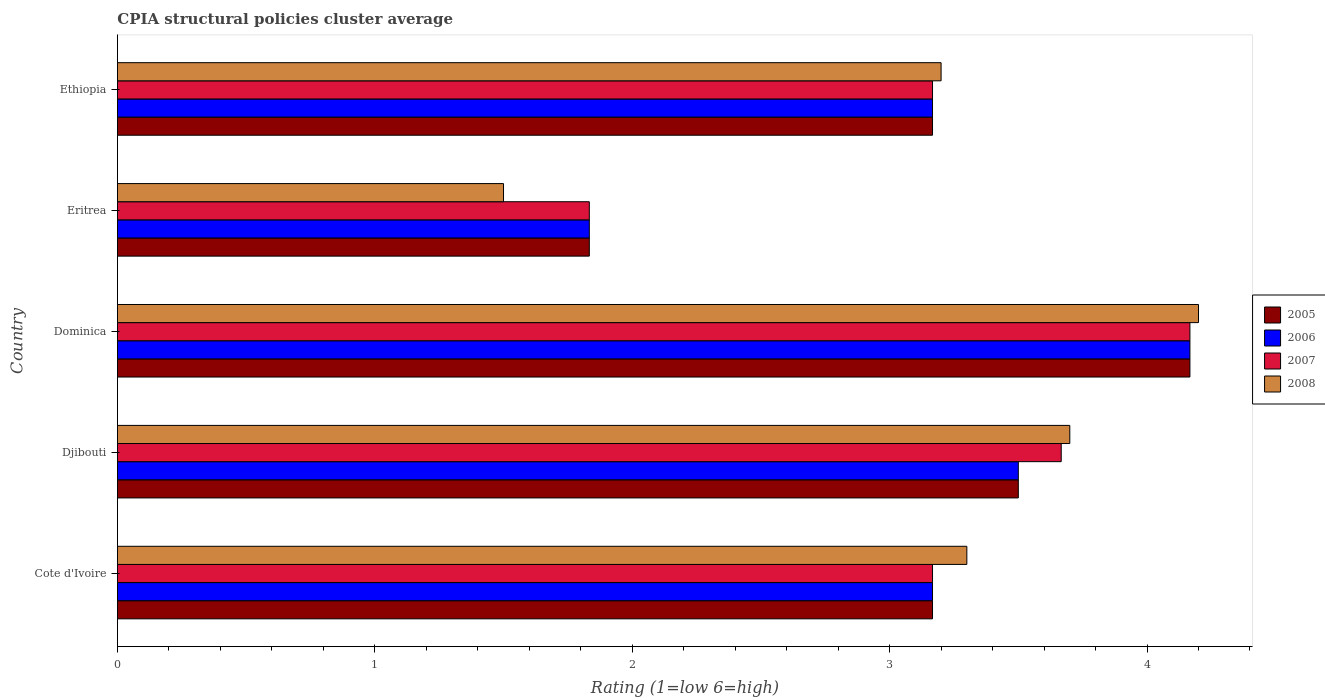How many groups of bars are there?
Ensure brevity in your answer.  5. Are the number of bars per tick equal to the number of legend labels?
Your answer should be compact. Yes. How many bars are there on the 2nd tick from the top?
Offer a very short reply. 4. What is the label of the 4th group of bars from the top?
Ensure brevity in your answer.  Djibouti. In how many cases, is the number of bars for a given country not equal to the number of legend labels?
Offer a terse response. 0. What is the CPIA rating in 2005 in Ethiopia?
Your answer should be compact. 3.17. Across all countries, what is the maximum CPIA rating in 2007?
Keep it short and to the point. 4.17. Across all countries, what is the minimum CPIA rating in 2005?
Give a very brief answer. 1.83. In which country was the CPIA rating in 2008 maximum?
Offer a terse response. Dominica. In which country was the CPIA rating in 2005 minimum?
Your answer should be very brief. Eritrea. What is the total CPIA rating in 2007 in the graph?
Keep it short and to the point. 16. What is the difference between the CPIA rating in 2005 in Cote d'Ivoire and that in Eritrea?
Keep it short and to the point. 1.33. What is the difference between the CPIA rating in 2005 in Ethiopia and the CPIA rating in 2006 in Djibouti?
Ensure brevity in your answer.  -0.33. What is the average CPIA rating in 2008 per country?
Provide a succinct answer. 3.18. What is the difference between the CPIA rating in 2005 and CPIA rating in 2007 in Djibouti?
Make the answer very short. -0.17. What is the ratio of the CPIA rating in 2006 in Dominica to that in Ethiopia?
Offer a terse response. 1.32. Is the difference between the CPIA rating in 2005 in Dominica and Eritrea greater than the difference between the CPIA rating in 2007 in Dominica and Eritrea?
Ensure brevity in your answer.  No. What is the difference between the highest and the second highest CPIA rating in 2006?
Your response must be concise. 0.67. What is the difference between the highest and the lowest CPIA rating in 2005?
Your response must be concise. 2.33. Is the sum of the CPIA rating in 2007 in Dominica and Ethiopia greater than the maximum CPIA rating in 2005 across all countries?
Give a very brief answer. Yes. What does the 3rd bar from the top in Dominica represents?
Give a very brief answer. 2006. Is it the case that in every country, the sum of the CPIA rating in 2008 and CPIA rating in 2006 is greater than the CPIA rating in 2005?
Provide a succinct answer. Yes. Are all the bars in the graph horizontal?
Your response must be concise. Yes. How many countries are there in the graph?
Provide a succinct answer. 5. What is the difference between two consecutive major ticks on the X-axis?
Make the answer very short. 1. Does the graph contain grids?
Your answer should be very brief. No. Where does the legend appear in the graph?
Offer a very short reply. Center right. What is the title of the graph?
Give a very brief answer. CPIA structural policies cluster average. Does "1968" appear as one of the legend labels in the graph?
Offer a very short reply. No. What is the label or title of the X-axis?
Your answer should be very brief. Rating (1=low 6=high). What is the Rating (1=low 6=high) of 2005 in Cote d'Ivoire?
Offer a terse response. 3.17. What is the Rating (1=low 6=high) of 2006 in Cote d'Ivoire?
Provide a succinct answer. 3.17. What is the Rating (1=low 6=high) of 2007 in Cote d'Ivoire?
Offer a terse response. 3.17. What is the Rating (1=low 6=high) of 2008 in Cote d'Ivoire?
Keep it short and to the point. 3.3. What is the Rating (1=low 6=high) in 2005 in Djibouti?
Provide a short and direct response. 3.5. What is the Rating (1=low 6=high) in 2007 in Djibouti?
Keep it short and to the point. 3.67. What is the Rating (1=low 6=high) in 2008 in Djibouti?
Give a very brief answer. 3.7. What is the Rating (1=low 6=high) in 2005 in Dominica?
Offer a very short reply. 4.17. What is the Rating (1=low 6=high) of 2006 in Dominica?
Your response must be concise. 4.17. What is the Rating (1=low 6=high) in 2007 in Dominica?
Give a very brief answer. 4.17. What is the Rating (1=low 6=high) in 2008 in Dominica?
Your response must be concise. 4.2. What is the Rating (1=low 6=high) of 2005 in Eritrea?
Make the answer very short. 1.83. What is the Rating (1=low 6=high) in 2006 in Eritrea?
Your response must be concise. 1.83. What is the Rating (1=low 6=high) of 2007 in Eritrea?
Keep it short and to the point. 1.83. What is the Rating (1=low 6=high) in 2005 in Ethiopia?
Your response must be concise. 3.17. What is the Rating (1=low 6=high) in 2006 in Ethiopia?
Provide a short and direct response. 3.17. What is the Rating (1=low 6=high) in 2007 in Ethiopia?
Provide a succinct answer. 3.17. What is the Rating (1=low 6=high) in 2008 in Ethiopia?
Your answer should be very brief. 3.2. Across all countries, what is the maximum Rating (1=low 6=high) in 2005?
Your answer should be very brief. 4.17. Across all countries, what is the maximum Rating (1=low 6=high) in 2006?
Your response must be concise. 4.17. Across all countries, what is the maximum Rating (1=low 6=high) in 2007?
Offer a terse response. 4.17. Across all countries, what is the maximum Rating (1=low 6=high) in 2008?
Your answer should be very brief. 4.2. Across all countries, what is the minimum Rating (1=low 6=high) of 2005?
Provide a succinct answer. 1.83. Across all countries, what is the minimum Rating (1=low 6=high) in 2006?
Give a very brief answer. 1.83. Across all countries, what is the minimum Rating (1=low 6=high) of 2007?
Your answer should be compact. 1.83. Across all countries, what is the minimum Rating (1=low 6=high) of 2008?
Provide a succinct answer. 1.5. What is the total Rating (1=low 6=high) in 2005 in the graph?
Provide a short and direct response. 15.83. What is the total Rating (1=low 6=high) of 2006 in the graph?
Give a very brief answer. 15.83. What is the total Rating (1=low 6=high) in 2008 in the graph?
Offer a terse response. 15.9. What is the difference between the Rating (1=low 6=high) of 2006 in Cote d'Ivoire and that in Djibouti?
Your answer should be very brief. -0.33. What is the difference between the Rating (1=low 6=high) in 2006 in Cote d'Ivoire and that in Dominica?
Make the answer very short. -1. What is the difference between the Rating (1=low 6=high) in 2007 in Cote d'Ivoire and that in Dominica?
Provide a short and direct response. -1. What is the difference between the Rating (1=low 6=high) in 2008 in Cote d'Ivoire and that in Eritrea?
Keep it short and to the point. 1.8. What is the difference between the Rating (1=low 6=high) of 2006 in Cote d'Ivoire and that in Ethiopia?
Your answer should be compact. 0. What is the difference between the Rating (1=low 6=high) of 2007 in Cote d'Ivoire and that in Ethiopia?
Your answer should be compact. 0. What is the difference between the Rating (1=low 6=high) in 2008 in Cote d'Ivoire and that in Ethiopia?
Provide a succinct answer. 0.1. What is the difference between the Rating (1=low 6=high) in 2007 in Djibouti and that in Eritrea?
Give a very brief answer. 1.83. What is the difference between the Rating (1=low 6=high) of 2008 in Djibouti and that in Eritrea?
Give a very brief answer. 2.2. What is the difference between the Rating (1=low 6=high) of 2006 in Djibouti and that in Ethiopia?
Your answer should be compact. 0.33. What is the difference between the Rating (1=low 6=high) of 2008 in Djibouti and that in Ethiopia?
Keep it short and to the point. 0.5. What is the difference between the Rating (1=low 6=high) in 2005 in Dominica and that in Eritrea?
Make the answer very short. 2.33. What is the difference between the Rating (1=low 6=high) in 2006 in Dominica and that in Eritrea?
Your answer should be compact. 2.33. What is the difference between the Rating (1=low 6=high) of 2007 in Dominica and that in Eritrea?
Your answer should be compact. 2.33. What is the difference between the Rating (1=low 6=high) in 2008 in Dominica and that in Eritrea?
Make the answer very short. 2.7. What is the difference between the Rating (1=low 6=high) in 2006 in Dominica and that in Ethiopia?
Provide a short and direct response. 1. What is the difference between the Rating (1=low 6=high) in 2008 in Dominica and that in Ethiopia?
Your response must be concise. 1. What is the difference between the Rating (1=low 6=high) in 2005 in Eritrea and that in Ethiopia?
Make the answer very short. -1.33. What is the difference between the Rating (1=low 6=high) in 2006 in Eritrea and that in Ethiopia?
Offer a very short reply. -1.33. What is the difference between the Rating (1=low 6=high) of 2007 in Eritrea and that in Ethiopia?
Ensure brevity in your answer.  -1.33. What is the difference between the Rating (1=low 6=high) in 2008 in Eritrea and that in Ethiopia?
Give a very brief answer. -1.7. What is the difference between the Rating (1=low 6=high) in 2005 in Cote d'Ivoire and the Rating (1=low 6=high) in 2008 in Djibouti?
Keep it short and to the point. -0.53. What is the difference between the Rating (1=low 6=high) in 2006 in Cote d'Ivoire and the Rating (1=low 6=high) in 2007 in Djibouti?
Offer a terse response. -0.5. What is the difference between the Rating (1=low 6=high) of 2006 in Cote d'Ivoire and the Rating (1=low 6=high) of 2008 in Djibouti?
Ensure brevity in your answer.  -0.53. What is the difference between the Rating (1=low 6=high) of 2007 in Cote d'Ivoire and the Rating (1=low 6=high) of 2008 in Djibouti?
Offer a terse response. -0.53. What is the difference between the Rating (1=low 6=high) in 2005 in Cote d'Ivoire and the Rating (1=low 6=high) in 2007 in Dominica?
Your answer should be compact. -1. What is the difference between the Rating (1=low 6=high) in 2005 in Cote d'Ivoire and the Rating (1=low 6=high) in 2008 in Dominica?
Give a very brief answer. -1.03. What is the difference between the Rating (1=low 6=high) in 2006 in Cote d'Ivoire and the Rating (1=low 6=high) in 2007 in Dominica?
Offer a terse response. -1. What is the difference between the Rating (1=low 6=high) of 2006 in Cote d'Ivoire and the Rating (1=low 6=high) of 2008 in Dominica?
Offer a very short reply. -1.03. What is the difference between the Rating (1=low 6=high) in 2007 in Cote d'Ivoire and the Rating (1=low 6=high) in 2008 in Dominica?
Make the answer very short. -1.03. What is the difference between the Rating (1=low 6=high) in 2005 in Cote d'Ivoire and the Rating (1=low 6=high) in 2006 in Eritrea?
Your response must be concise. 1.33. What is the difference between the Rating (1=low 6=high) of 2005 in Cote d'Ivoire and the Rating (1=low 6=high) of 2007 in Eritrea?
Provide a short and direct response. 1.33. What is the difference between the Rating (1=low 6=high) in 2007 in Cote d'Ivoire and the Rating (1=low 6=high) in 2008 in Eritrea?
Provide a short and direct response. 1.67. What is the difference between the Rating (1=low 6=high) in 2005 in Cote d'Ivoire and the Rating (1=low 6=high) in 2006 in Ethiopia?
Your answer should be compact. 0. What is the difference between the Rating (1=low 6=high) of 2005 in Cote d'Ivoire and the Rating (1=low 6=high) of 2007 in Ethiopia?
Provide a succinct answer. 0. What is the difference between the Rating (1=low 6=high) in 2005 in Cote d'Ivoire and the Rating (1=low 6=high) in 2008 in Ethiopia?
Your answer should be compact. -0.03. What is the difference between the Rating (1=low 6=high) in 2006 in Cote d'Ivoire and the Rating (1=low 6=high) in 2008 in Ethiopia?
Make the answer very short. -0.03. What is the difference between the Rating (1=low 6=high) in 2007 in Cote d'Ivoire and the Rating (1=low 6=high) in 2008 in Ethiopia?
Keep it short and to the point. -0.03. What is the difference between the Rating (1=low 6=high) in 2005 in Djibouti and the Rating (1=low 6=high) in 2006 in Dominica?
Offer a terse response. -0.67. What is the difference between the Rating (1=low 6=high) in 2005 in Djibouti and the Rating (1=low 6=high) in 2007 in Dominica?
Provide a succinct answer. -0.67. What is the difference between the Rating (1=low 6=high) of 2005 in Djibouti and the Rating (1=low 6=high) of 2008 in Dominica?
Offer a very short reply. -0.7. What is the difference between the Rating (1=low 6=high) in 2006 in Djibouti and the Rating (1=low 6=high) in 2007 in Dominica?
Make the answer very short. -0.67. What is the difference between the Rating (1=low 6=high) in 2006 in Djibouti and the Rating (1=low 6=high) in 2008 in Dominica?
Provide a short and direct response. -0.7. What is the difference between the Rating (1=low 6=high) in 2007 in Djibouti and the Rating (1=low 6=high) in 2008 in Dominica?
Your response must be concise. -0.53. What is the difference between the Rating (1=low 6=high) in 2005 in Djibouti and the Rating (1=low 6=high) in 2006 in Eritrea?
Your answer should be very brief. 1.67. What is the difference between the Rating (1=low 6=high) of 2005 in Djibouti and the Rating (1=low 6=high) of 2007 in Eritrea?
Provide a short and direct response. 1.67. What is the difference between the Rating (1=low 6=high) of 2006 in Djibouti and the Rating (1=low 6=high) of 2007 in Eritrea?
Your response must be concise. 1.67. What is the difference between the Rating (1=low 6=high) of 2007 in Djibouti and the Rating (1=low 6=high) of 2008 in Eritrea?
Provide a short and direct response. 2.17. What is the difference between the Rating (1=low 6=high) in 2005 in Djibouti and the Rating (1=low 6=high) in 2006 in Ethiopia?
Provide a short and direct response. 0.33. What is the difference between the Rating (1=low 6=high) in 2005 in Djibouti and the Rating (1=low 6=high) in 2007 in Ethiopia?
Provide a succinct answer. 0.33. What is the difference between the Rating (1=low 6=high) in 2005 in Djibouti and the Rating (1=low 6=high) in 2008 in Ethiopia?
Make the answer very short. 0.3. What is the difference between the Rating (1=low 6=high) of 2006 in Djibouti and the Rating (1=low 6=high) of 2007 in Ethiopia?
Make the answer very short. 0.33. What is the difference between the Rating (1=low 6=high) of 2006 in Djibouti and the Rating (1=low 6=high) of 2008 in Ethiopia?
Make the answer very short. 0.3. What is the difference between the Rating (1=low 6=high) of 2007 in Djibouti and the Rating (1=low 6=high) of 2008 in Ethiopia?
Give a very brief answer. 0.47. What is the difference between the Rating (1=low 6=high) of 2005 in Dominica and the Rating (1=low 6=high) of 2006 in Eritrea?
Keep it short and to the point. 2.33. What is the difference between the Rating (1=low 6=high) of 2005 in Dominica and the Rating (1=low 6=high) of 2007 in Eritrea?
Your response must be concise. 2.33. What is the difference between the Rating (1=low 6=high) of 2005 in Dominica and the Rating (1=low 6=high) of 2008 in Eritrea?
Provide a succinct answer. 2.67. What is the difference between the Rating (1=low 6=high) in 2006 in Dominica and the Rating (1=low 6=high) in 2007 in Eritrea?
Give a very brief answer. 2.33. What is the difference between the Rating (1=low 6=high) of 2006 in Dominica and the Rating (1=low 6=high) of 2008 in Eritrea?
Offer a terse response. 2.67. What is the difference between the Rating (1=low 6=high) of 2007 in Dominica and the Rating (1=low 6=high) of 2008 in Eritrea?
Provide a short and direct response. 2.67. What is the difference between the Rating (1=low 6=high) in 2005 in Dominica and the Rating (1=low 6=high) in 2006 in Ethiopia?
Make the answer very short. 1. What is the difference between the Rating (1=low 6=high) in 2005 in Dominica and the Rating (1=low 6=high) in 2007 in Ethiopia?
Offer a very short reply. 1. What is the difference between the Rating (1=low 6=high) of 2005 in Dominica and the Rating (1=low 6=high) of 2008 in Ethiopia?
Your answer should be very brief. 0.97. What is the difference between the Rating (1=low 6=high) of 2006 in Dominica and the Rating (1=low 6=high) of 2008 in Ethiopia?
Ensure brevity in your answer.  0.97. What is the difference between the Rating (1=low 6=high) in 2007 in Dominica and the Rating (1=low 6=high) in 2008 in Ethiopia?
Keep it short and to the point. 0.97. What is the difference between the Rating (1=low 6=high) of 2005 in Eritrea and the Rating (1=low 6=high) of 2006 in Ethiopia?
Keep it short and to the point. -1.33. What is the difference between the Rating (1=low 6=high) in 2005 in Eritrea and the Rating (1=low 6=high) in 2007 in Ethiopia?
Make the answer very short. -1.33. What is the difference between the Rating (1=low 6=high) of 2005 in Eritrea and the Rating (1=low 6=high) of 2008 in Ethiopia?
Offer a very short reply. -1.37. What is the difference between the Rating (1=low 6=high) in 2006 in Eritrea and the Rating (1=low 6=high) in 2007 in Ethiopia?
Your answer should be very brief. -1.33. What is the difference between the Rating (1=low 6=high) in 2006 in Eritrea and the Rating (1=low 6=high) in 2008 in Ethiopia?
Make the answer very short. -1.37. What is the difference between the Rating (1=low 6=high) of 2007 in Eritrea and the Rating (1=low 6=high) of 2008 in Ethiopia?
Your answer should be very brief. -1.37. What is the average Rating (1=low 6=high) of 2005 per country?
Offer a very short reply. 3.17. What is the average Rating (1=low 6=high) of 2006 per country?
Offer a very short reply. 3.17. What is the average Rating (1=low 6=high) of 2007 per country?
Your answer should be compact. 3.2. What is the average Rating (1=low 6=high) in 2008 per country?
Make the answer very short. 3.18. What is the difference between the Rating (1=low 6=high) in 2005 and Rating (1=low 6=high) in 2006 in Cote d'Ivoire?
Keep it short and to the point. 0. What is the difference between the Rating (1=low 6=high) of 2005 and Rating (1=low 6=high) of 2008 in Cote d'Ivoire?
Offer a terse response. -0.13. What is the difference between the Rating (1=low 6=high) in 2006 and Rating (1=low 6=high) in 2007 in Cote d'Ivoire?
Give a very brief answer. 0. What is the difference between the Rating (1=low 6=high) of 2006 and Rating (1=low 6=high) of 2008 in Cote d'Ivoire?
Offer a terse response. -0.13. What is the difference between the Rating (1=low 6=high) of 2007 and Rating (1=low 6=high) of 2008 in Cote d'Ivoire?
Keep it short and to the point. -0.13. What is the difference between the Rating (1=low 6=high) of 2005 and Rating (1=low 6=high) of 2007 in Djibouti?
Provide a succinct answer. -0.17. What is the difference between the Rating (1=low 6=high) of 2006 and Rating (1=low 6=high) of 2007 in Djibouti?
Your response must be concise. -0.17. What is the difference between the Rating (1=low 6=high) of 2007 and Rating (1=low 6=high) of 2008 in Djibouti?
Give a very brief answer. -0.03. What is the difference between the Rating (1=low 6=high) in 2005 and Rating (1=low 6=high) in 2008 in Dominica?
Keep it short and to the point. -0.03. What is the difference between the Rating (1=low 6=high) in 2006 and Rating (1=low 6=high) in 2007 in Dominica?
Your answer should be compact. 0. What is the difference between the Rating (1=low 6=high) in 2006 and Rating (1=low 6=high) in 2008 in Dominica?
Ensure brevity in your answer.  -0.03. What is the difference between the Rating (1=low 6=high) in 2007 and Rating (1=low 6=high) in 2008 in Dominica?
Offer a terse response. -0.03. What is the difference between the Rating (1=low 6=high) of 2005 and Rating (1=low 6=high) of 2006 in Eritrea?
Your answer should be compact. 0. What is the difference between the Rating (1=low 6=high) in 2005 and Rating (1=low 6=high) in 2007 in Eritrea?
Your response must be concise. 0. What is the difference between the Rating (1=low 6=high) in 2006 and Rating (1=low 6=high) in 2007 in Eritrea?
Keep it short and to the point. 0. What is the difference between the Rating (1=low 6=high) in 2005 and Rating (1=low 6=high) in 2007 in Ethiopia?
Provide a short and direct response. 0. What is the difference between the Rating (1=low 6=high) of 2005 and Rating (1=low 6=high) of 2008 in Ethiopia?
Your answer should be compact. -0.03. What is the difference between the Rating (1=low 6=high) in 2006 and Rating (1=low 6=high) in 2008 in Ethiopia?
Your response must be concise. -0.03. What is the difference between the Rating (1=low 6=high) in 2007 and Rating (1=low 6=high) in 2008 in Ethiopia?
Provide a succinct answer. -0.03. What is the ratio of the Rating (1=low 6=high) in 2005 in Cote d'Ivoire to that in Djibouti?
Give a very brief answer. 0.9. What is the ratio of the Rating (1=low 6=high) of 2006 in Cote d'Ivoire to that in Djibouti?
Keep it short and to the point. 0.9. What is the ratio of the Rating (1=low 6=high) in 2007 in Cote d'Ivoire to that in Djibouti?
Offer a terse response. 0.86. What is the ratio of the Rating (1=low 6=high) in 2008 in Cote d'Ivoire to that in Djibouti?
Provide a short and direct response. 0.89. What is the ratio of the Rating (1=low 6=high) in 2005 in Cote d'Ivoire to that in Dominica?
Provide a succinct answer. 0.76. What is the ratio of the Rating (1=low 6=high) in 2006 in Cote d'Ivoire to that in Dominica?
Provide a succinct answer. 0.76. What is the ratio of the Rating (1=low 6=high) in 2007 in Cote d'Ivoire to that in Dominica?
Give a very brief answer. 0.76. What is the ratio of the Rating (1=low 6=high) of 2008 in Cote d'Ivoire to that in Dominica?
Ensure brevity in your answer.  0.79. What is the ratio of the Rating (1=low 6=high) of 2005 in Cote d'Ivoire to that in Eritrea?
Keep it short and to the point. 1.73. What is the ratio of the Rating (1=low 6=high) in 2006 in Cote d'Ivoire to that in Eritrea?
Your answer should be very brief. 1.73. What is the ratio of the Rating (1=low 6=high) of 2007 in Cote d'Ivoire to that in Eritrea?
Ensure brevity in your answer.  1.73. What is the ratio of the Rating (1=low 6=high) of 2008 in Cote d'Ivoire to that in Eritrea?
Provide a short and direct response. 2.2. What is the ratio of the Rating (1=low 6=high) in 2006 in Cote d'Ivoire to that in Ethiopia?
Your response must be concise. 1. What is the ratio of the Rating (1=low 6=high) in 2008 in Cote d'Ivoire to that in Ethiopia?
Ensure brevity in your answer.  1.03. What is the ratio of the Rating (1=low 6=high) of 2005 in Djibouti to that in Dominica?
Offer a terse response. 0.84. What is the ratio of the Rating (1=low 6=high) of 2006 in Djibouti to that in Dominica?
Provide a succinct answer. 0.84. What is the ratio of the Rating (1=low 6=high) in 2008 in Djibouti to that in Dominica?
Make the answer very short. 0.88. What is the ratio of the Rating (1=low 6=high) in 2005 in Djibouti to that in Eritrea?
Provide a short and direct response. 1.91. What is the ratio of the Rating (1=low 6=high) in 2006 in Djibouti to that in Eritrea?
Give a very brief answer. 1.91. What is the ratio of the Rating (1=low 6=high) in 2007 in Djibouti to that in Eritrea?
Your answer should be compact. 2. What is the ratio of the Rating (1=low 6=high) in 2008 in Djibouti to that in Eritrea?
Your response must be concise. 2.47. What is the ratio of the Rating (1=low 6=high) in 2005 in Djibouti to that in Ethiopia?
Provide a succinct answer. 1.11. What is the ratio of the Rating (1=low 6=high) of 2006 in Djibouti to that in Ethiopia?
Ensure brevity in your answer.  1.11. What is the ratio of the Rating (1=low 6=high) in 2007 in Djibouti to that in Ethiopia?
Provide a succinct answer. 1.16. What is the ratio of the Rating (1=low 6=high) of 2008 in Djibouti to that in Ethiopia?
Make the answer very short. 1.16. What is the ratio of the Rating (1=low 6=high) in 2005 in Dominica to that in Eritrea?
Make the answer very short. 2.27. What is the ratio of the Rating (1=low 6=high) in 2006 in Dominica to that in Eritrea?
Your answer should be very brief. 2.27. What is the ratio of the Rating (1=low 6=high) of 2007 in Dominica to that in Eritrea?
Keep it short and to the point. 2.27. What is the ratio of the Rating (1=low 6=high) of 2008 in Dominica to that in Eritrea?
Your answer should be compact. 2.8. What is the ratio of the Rating (1=low 6=high) of 2005 in Dominica to that in Ethiopia?
Your response must be concise. 1.32. What is the ratio of the Rating (1=low 6=high) in 2006 in Dominica to that in Ethiopia?
Your response must be concise. 1.32. What is the ratio of the Rating (1=low 6=high) in 2007 in Dominica to that in Ethiopia?
Offer a very short reply. 1.32. What is the ratio of the Rating (1=low 6=high) in 2008 in Dominica to that in Ethiopia?
Keep it short and to the point. 1.31. What is the ratio of the Rating (1=low 6=high) in 2005 in Eritrea to that in Ethiopia?
Give a very brief answer. 0.58. What is the ratio of the Rating (1=low 6=high) in 2006 in Eritrea to that in Ethiopia?
Provide a succinct answer. 0.58. What is the ratio of the Rating (1=low 6=high) of 2007 in Eritrea to that in Ethiopia?
Ensure brevity in your answer.  0.58. What is the ratio of the Rating (1=low 6=high) in 2008 in Eritrea to that in Ethiopia?
Make the answer very short. 0.47. What is the difference between the highest and the second highest Rating (1=low 6=high) of 2007?
Give a very brief answer. 0.5. What is the difference between the highest and the second highest Rating (1=low 6=high) of 2008?
Offer a very short reply. 0.5. What is the difference between the highest and the lowest Rating (1=low 6=high) in 2005?
Offer a terse response. 2.33. What is the difference between the highest and the lowest Rating (1=low 6=high) in 2006?
Your response must be concise. 2.33. What is the difference between the highest and the lowest Rating (1=low 6=high) of 2007?
Provide a short and direct response. 2.33. What is the difference between the highest and the lowest Rating (1=low 6=high) in 2008?
Your response must be concise. 2.7. 